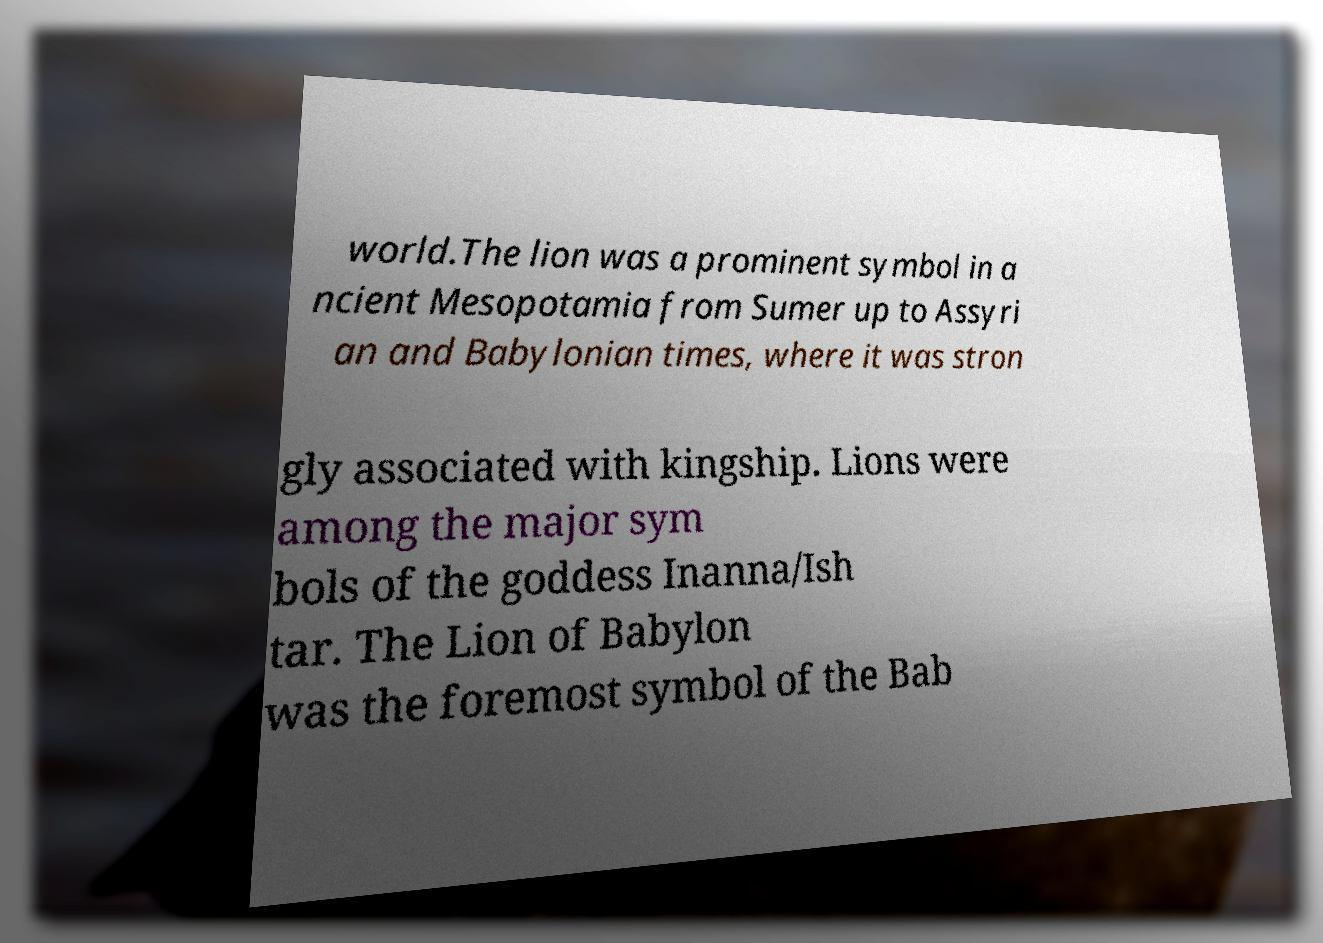Can you read and provide the text displayed in the image?This photo seems to have some interesting text. Can you extract and type it out for me? world.The lion was a prominent symbol in a ncient Mesopotamia from Sumer up to Assyri an and Babylonian times, where it was stron gly associated with kingship. Lions were among the major sym bols of the goddess Inanna/Ish tar. The Lion of Babylon was the foremost symbol of the Bab 